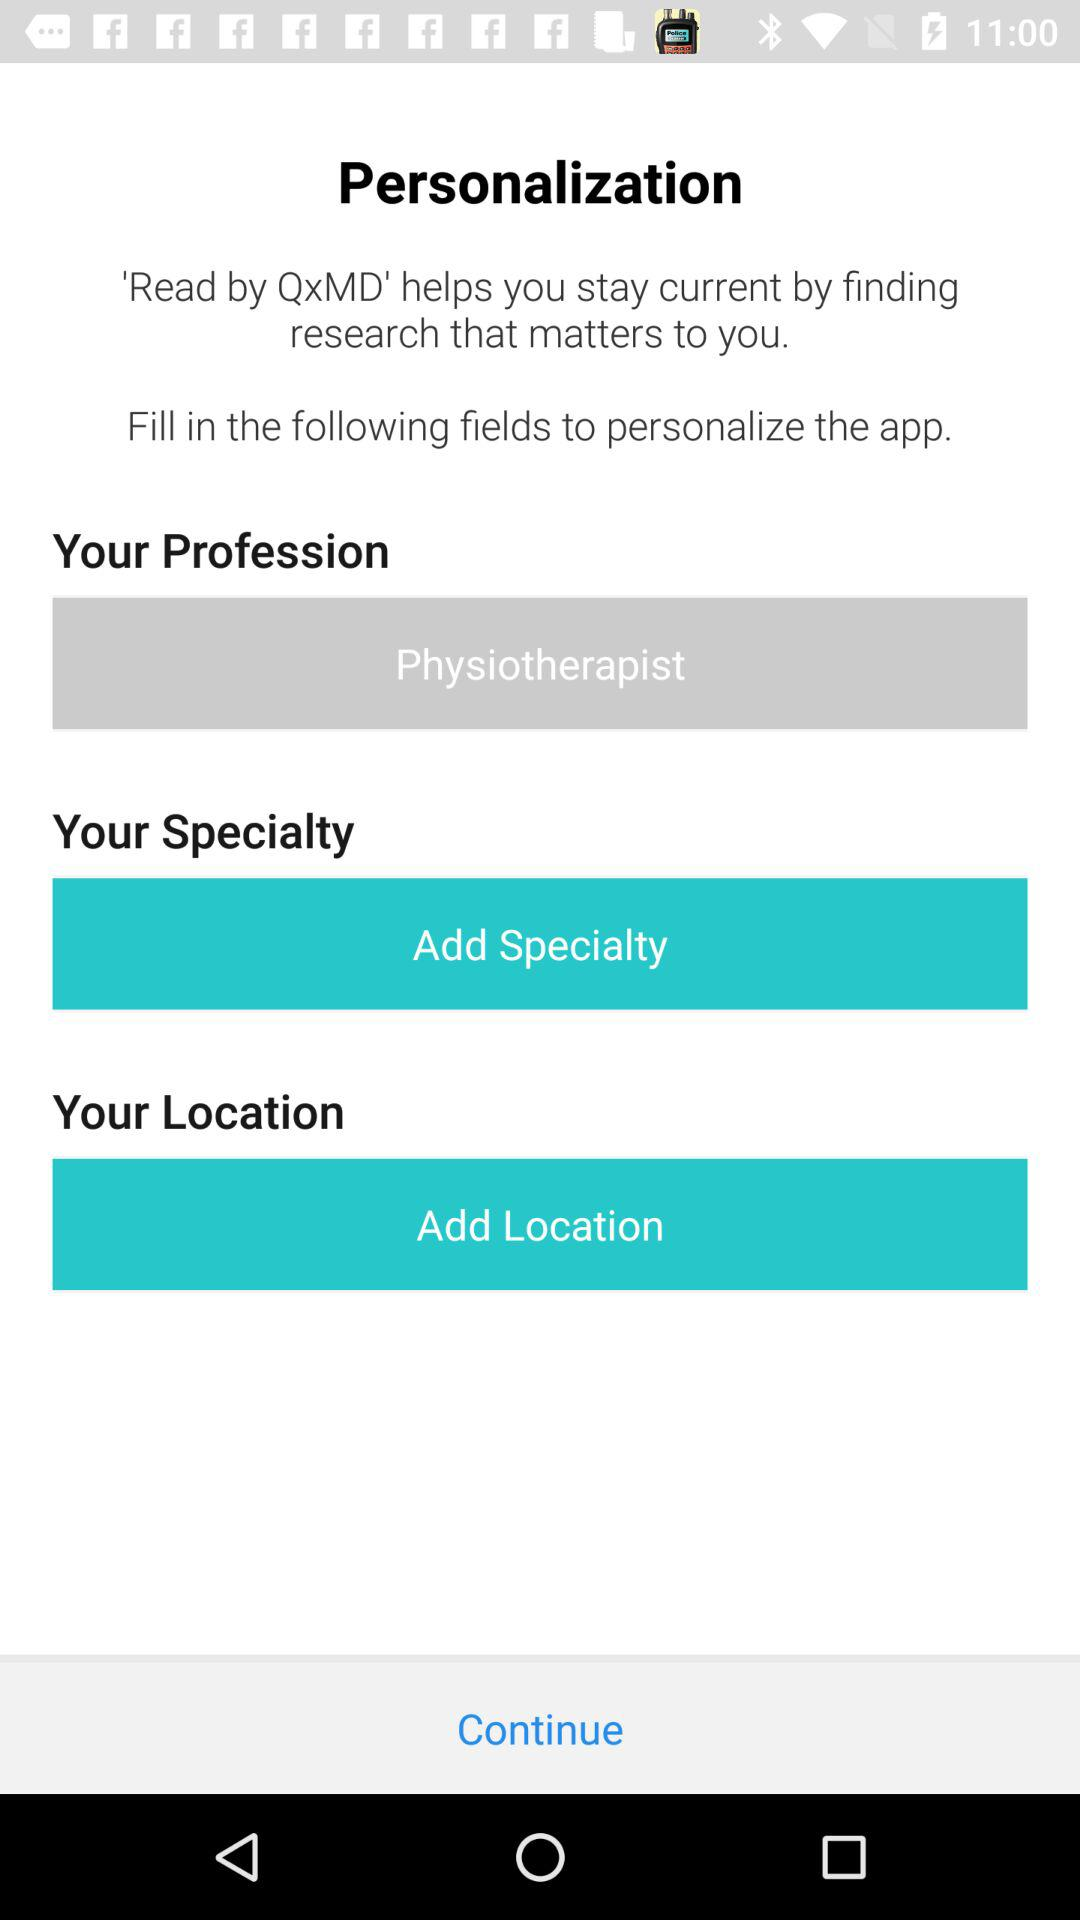How many fields are there to personalize the app?
Answer the question using a single word or phrase. 3 